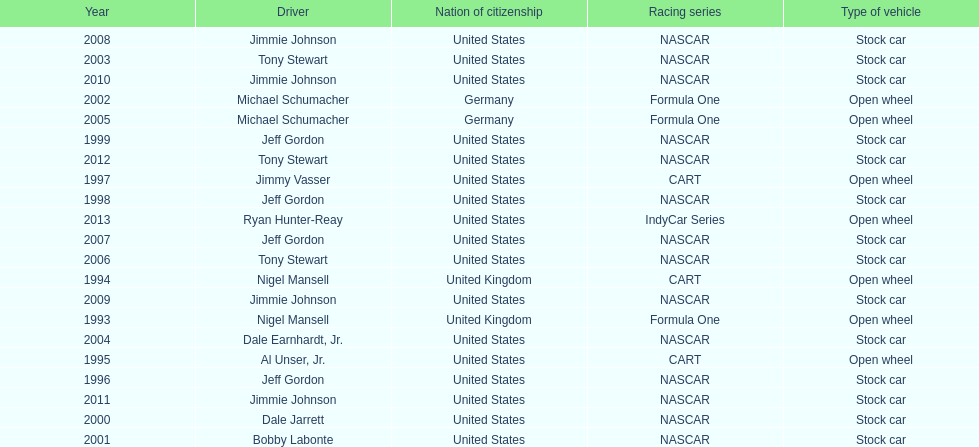Besides nascar, what other racing series have espy-winning drivers come from? Formula One, CART, IndyCar Series. 